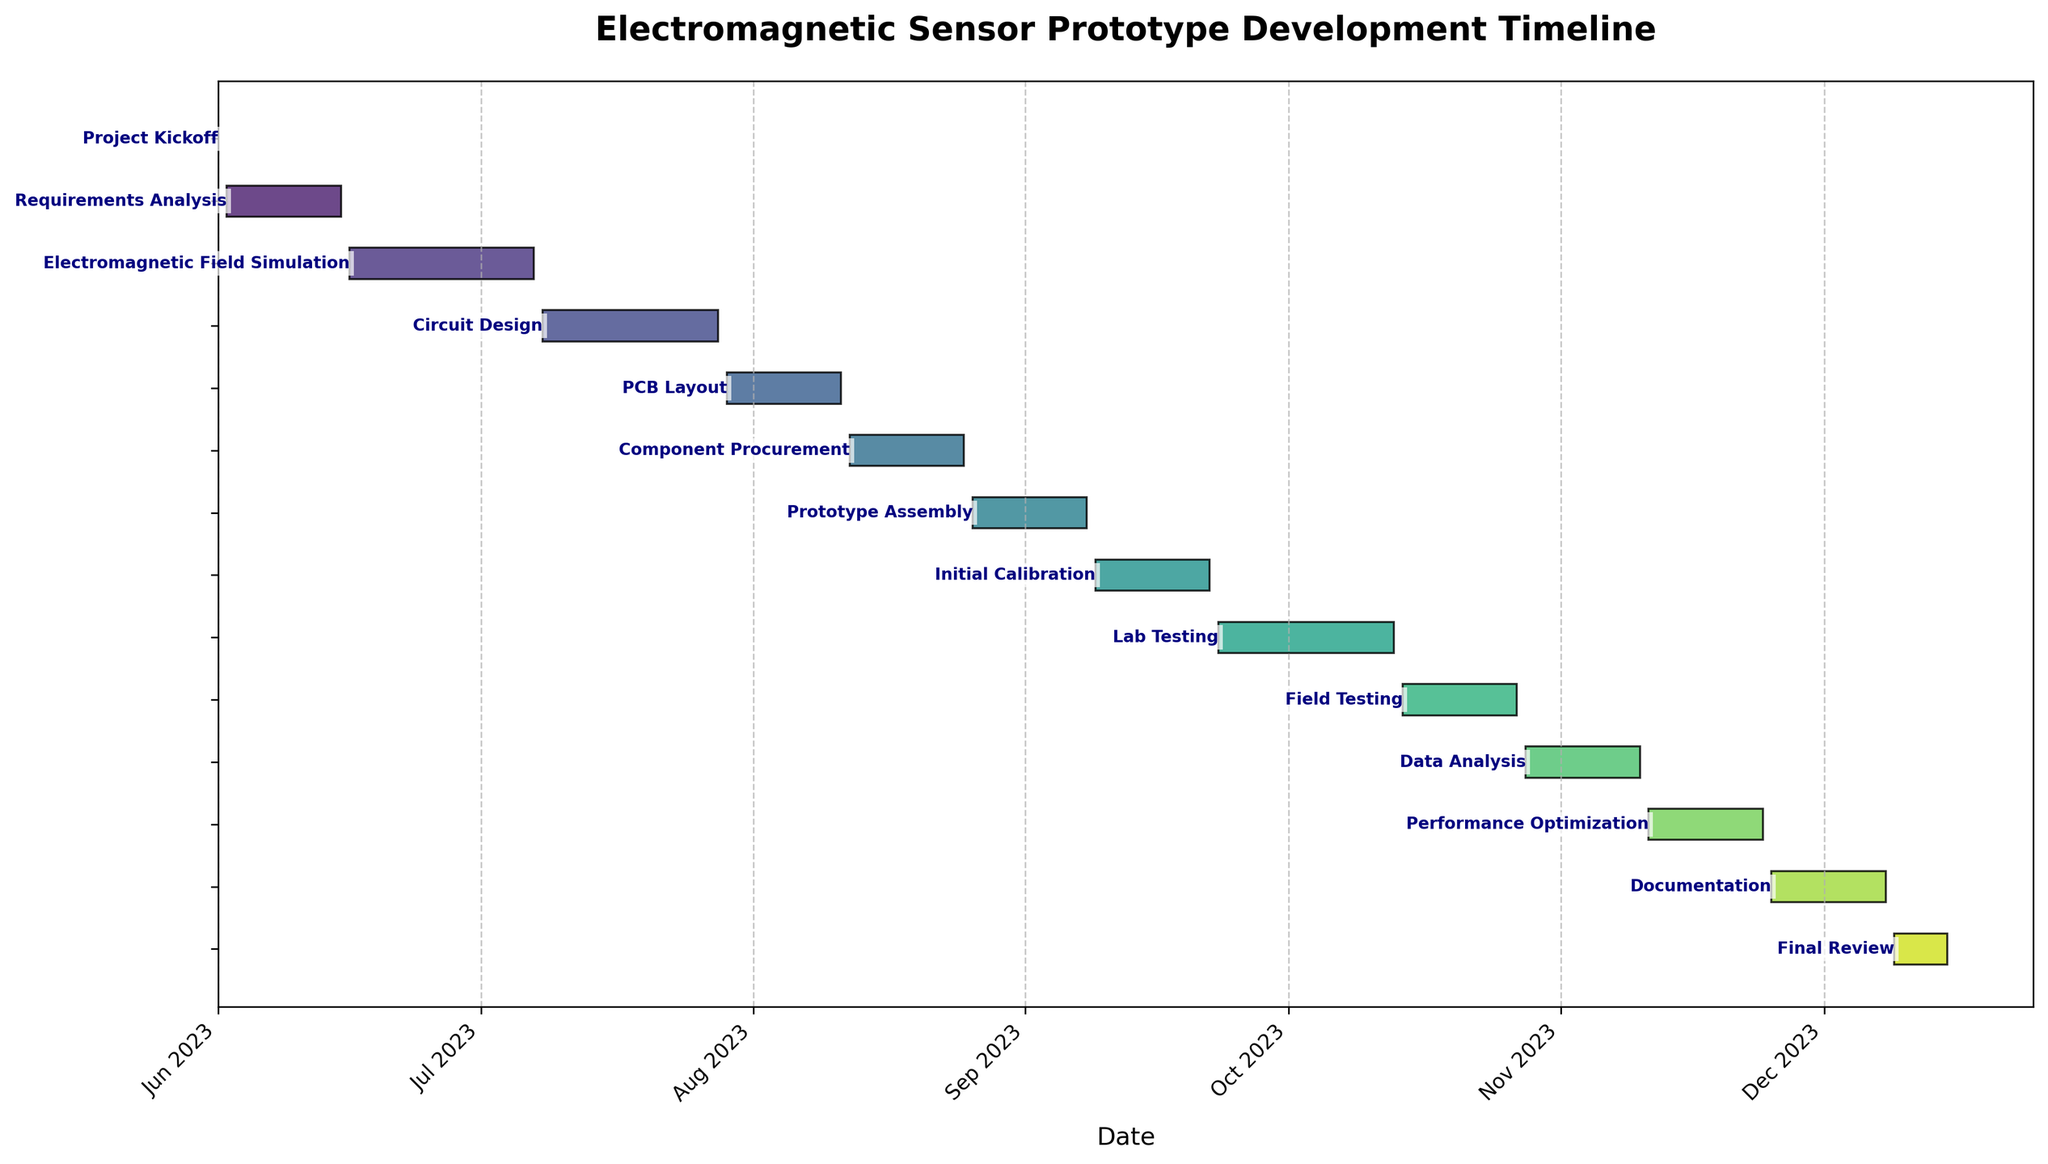What is the title of the Gantt chart? The title of a figure is typically found at the top, usually in bold or larger font compared to other text.
Answer: Electromagnetic Sensor Prototype Development Timeline Which task spans the longest duration? To find the task with the longest duration, check the length of each task's bar in the Gantt chart, representing the number of days each task takes.
Answer: Electromagnetic Field Simulation When does the Data Analysis task begin and end? Find the Data Analysis task in the vertical list, then follow the corresponding bar to its start and end points on the timeline.
Answer: October 28, 2023 to November 10, 2023 How many tasks are planned to start in August 2023? Look for tasks whose bars begin within the August 2023 section of the timeline. Count these tasks.
Answer: 3 tasks (PCB Layout, Component Procurement, Prototype Assembly) Which tasks run simultaneously in September 2023? Identify the overlapping time frames of tasks that begin or end in September by observing if their bars overlap within that month.
Answer: Initial Calibration and Lab Testing What is the average duration of tasks? Calculate the duration of each task shown in the chart, sum them up, and divide by the total number of tasks. Detailed calculation:
(1 + 14 + 22 + 21 + 14 + 14 + 14 + 14 + 21 + 14 + 14 + 14 + 14 + 7) / 14 = 189 / 14
Answer: 13.5 days Which task ends last on the timeline? Identify the task whose bar ends furthest to the right on the timeline.
Answer: Final Review Is there any break period between the Prototype Assembly and Initial Calibration tasks? Check the end date of the Prototype Assembly task and the start date of the Initial Calibration task to see if there is a gap between their corresponding bars in the timeline.
Answer: No How long does the entire project take from start to finish? Identify the start date of the first task and the end date of the last task, then calculate the total duration.
Answer: 198 days During which months do the Field Testing tasks take place? Locate the Field Testing task on the timeline and note the months it spans.
Answer: October 2023 